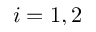Convert formula to latex. <formula><loc_0><loc_0><loc_500><loc_500>i = 1 , 2</formula> 